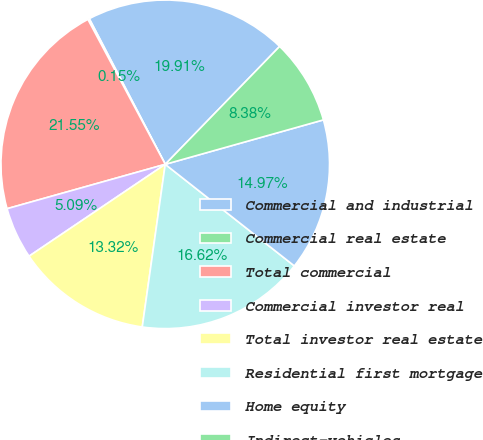Convert chart to OTSL. <chart><loc_0><loc_0><loc_500><loc_500><pie_chart><fcel>Commercial and industrial<fcel>Commercial real estate<fcel>Total commercial<fcel>Commercial investor real<fcel>Total investor real estate<fcel>Residential first mortgage<fcel>Home equity<fcel>Indirect-vehicles<nl><fcel>19.91%<fcel>0.15%<fcel>21.55%<fcel>5.09%<fcel>13.32%<fcel>16.62%<fcel>14.97%<fcel>8.38%<nl></chart> 